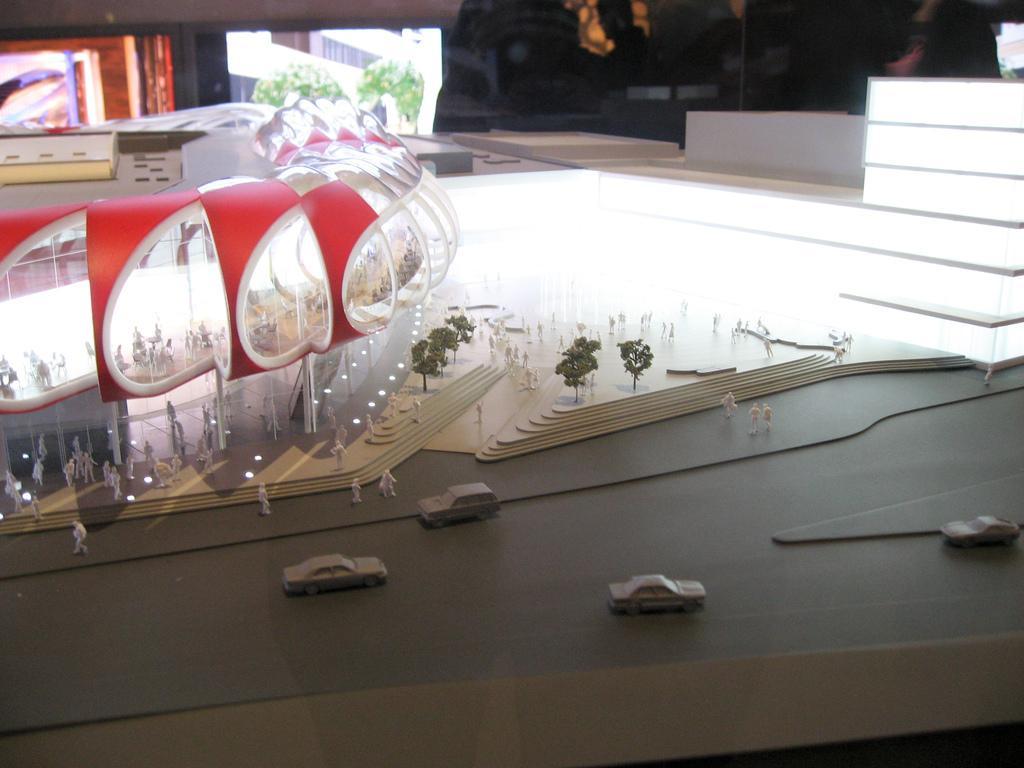Please provide a concise description of this image. In this picture I can see scale model buildings, there are toy cars, toy trees, and in the background there are some objects. 